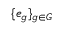<formula> <loc_0><loc_0><loc_500><loc_500>\{ e _ { g } \} _ { g \in G }</formula> 